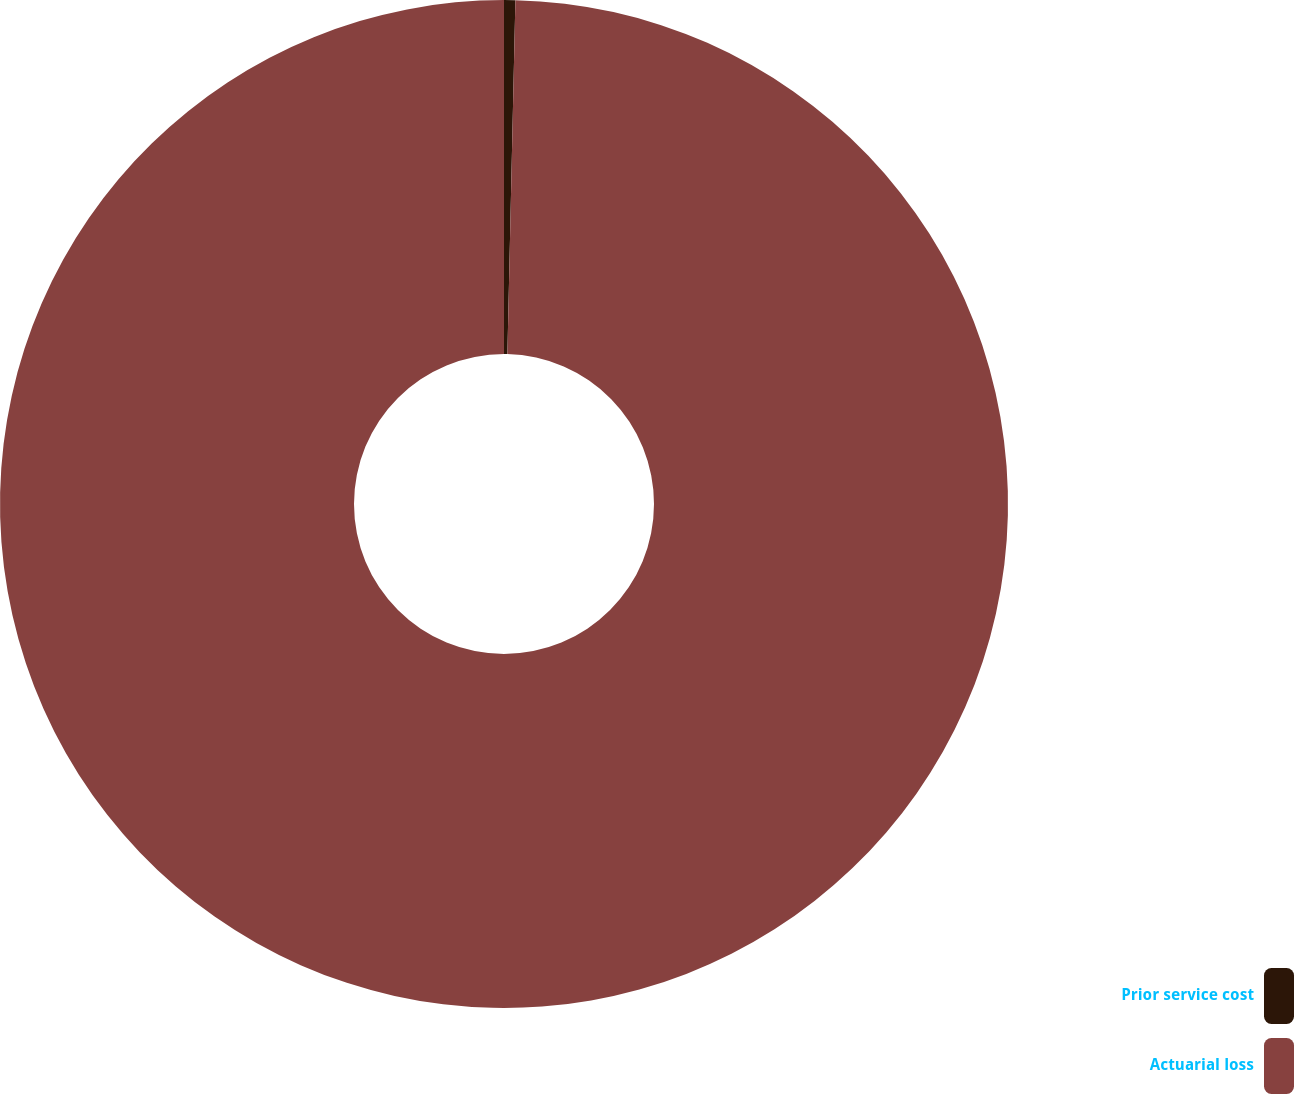<chart> <loc_0><loc_0><loc_500><loc_500><pie_chart><fcel>Prior service cost<fcel>Actuarial loss<nl><fcel>0.36%<fcel>99.64%<nl></chart> 